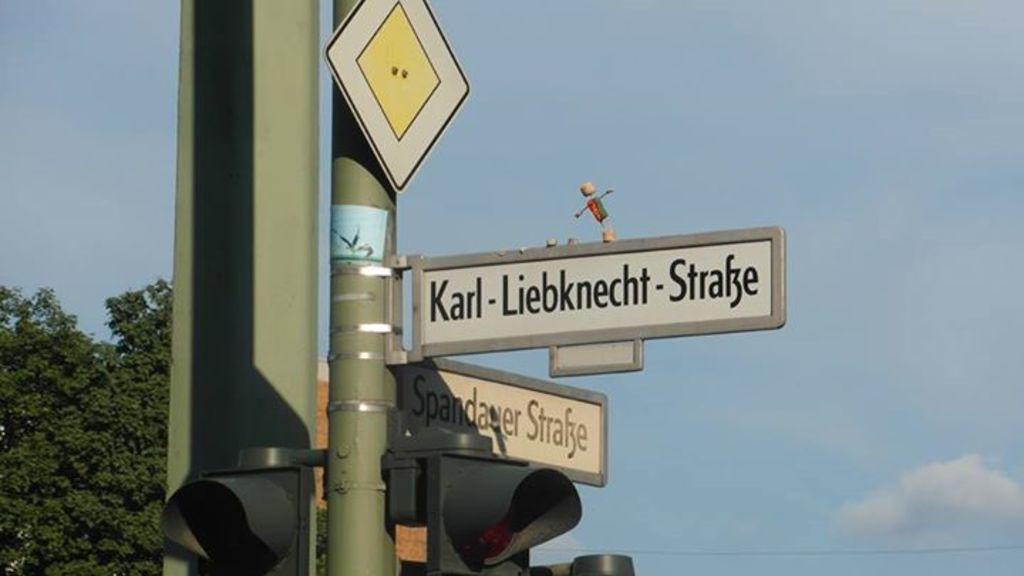How would you summarize this image in a sentence or two? In this image I can see traffic signal, background I can see few boards attached to the pole, trees in green color and sky in blue and white color. 